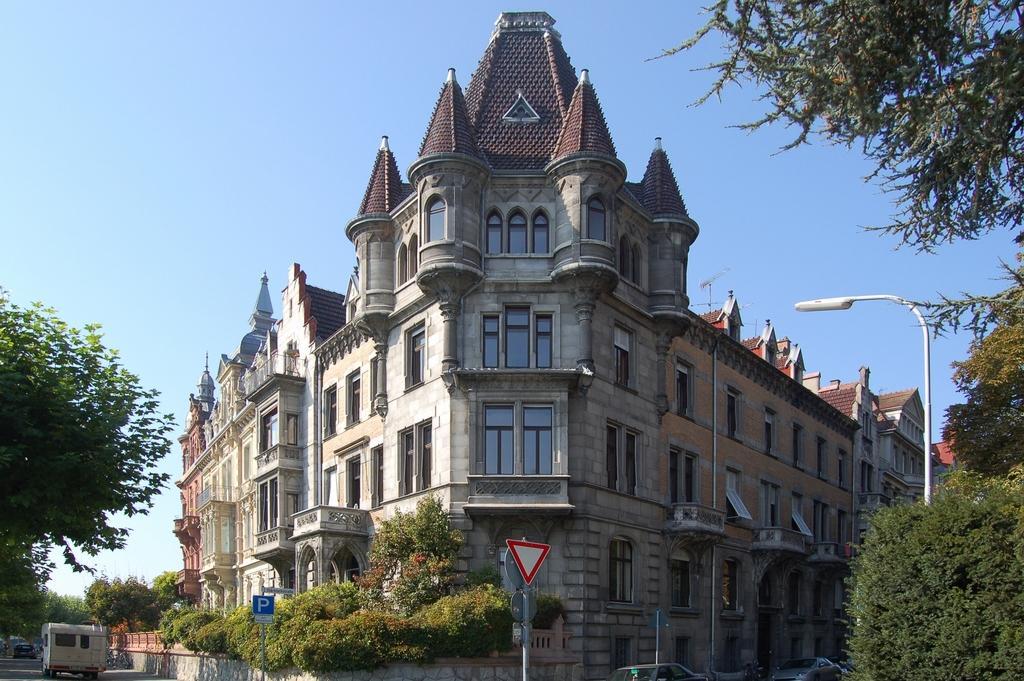How would you summarize this image in a sentence or two? It is a big building and in the right side there are trees. In the left side there is a vehicle moving on the road. 